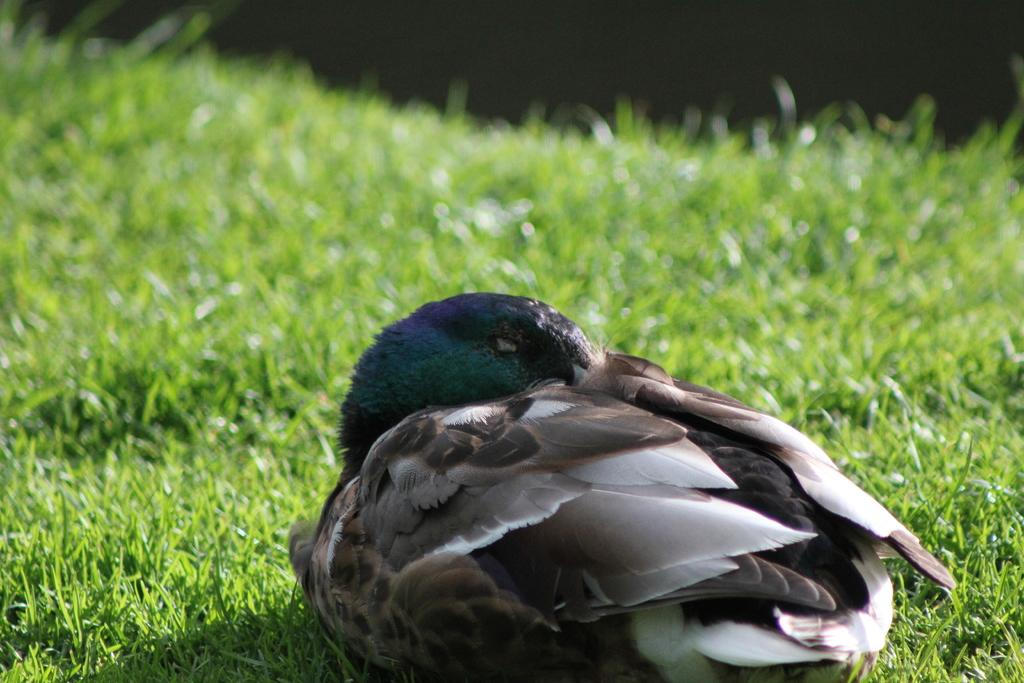What type of animal is in the image? There is a bird in the image. Where is the bird located? The bird is on the grass. Can you describe the background of the image? The background of the image is blurred. What type of suit is the bird wearing in the image? There is no suit present in the image; it features a bird on the grass with a blurred background. 